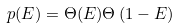<formula> <loc_0><loc_0><loc_500><loc_500>p ( E ) = \Theta ( E ) \Theta \left ( 1 - E \right )</formula> 